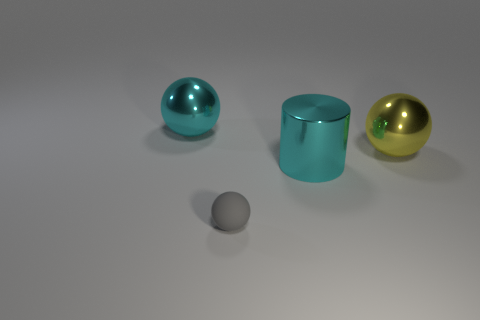What size is the matte thing that is the same shape as the yellow metal thing?
Your response must be concise. Small. Are there an equal number of large cyan objects that are in front of the tiny gray sphere and tiny gray cylinders?
Provide a short and direct response. Yes. There is a big cyan thing right of the large cyan metallic ball; is it the same shape as the gray thing?
Your answer should be very brief. No. There is a tiny rubber thing; what shape is it?
Offer a very short reply. Sphere. What material is the cyan thing in front of the large cyan metallic thing behind the big yellow metal object that is to the right of the big cyan sphere?
Ensure brevity in your answer.  Metal. There is a sphere that is the same color as the large metal cylinder; what is it made of?
Give a very brief answer. Metal. How many objects are either big metal spheres or tiny cyan matte cubes?
Your response must be concise. 2. Does the thing that is to the left of the gray object have the same material as the yellow ball?
Offer a terse response. Yes. What number of things are either big metallic objects on the left side of the yellow object or large shiny cylinders?
Give a very brief answer. 2. There is another ball that is made of the same material as the cyan sphere; what is its color?
Provide a short and direct response. Yellow. 